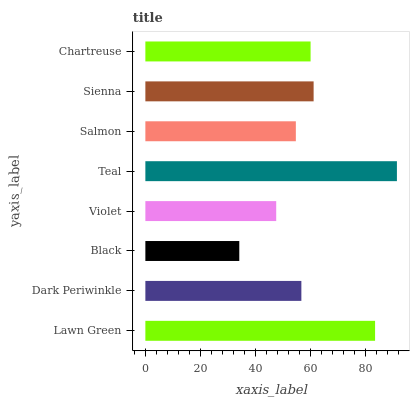Is Black the minimum?
Answer yes or no. Yes. Is Teal the maximum?
Answer yes or no. Yes. Is Dark Periwinkle the minimum?
Answer yes or no. No. Is Dark Periwinkle the maximum?
Answer yes or no. No. Is Lawn Green greater than Dark Periwinkle?
Answer yes or no. Yes. Is Dark Periwinkle less than Lawn Green?
Answer yes or no. Yes. Is Dark Periwinkle greater than Lawn Green?
Answer yes or no. No. Is Lawn Green less than Dark Periwinkle?
Answer yes or no. No. Is Chartreuse the high median?
Answer yes or no. Yes. Is Dark Periwinkle the low median?
Answer yes or no. Yes. Is Salmon the high median?
Answer yes or no. No. Is Violet the low median?
Answer yes or no. No. 